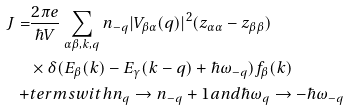<formula> <loc_0><loc_0><loc_500><loc_500>J = & \frac { 2 \pi e } { \hbar { V } } \sum _ { \alpha \beta , { k } , { q } } n _ { - { q } } | V _ { \beta \alpha } ( { q } ) | ^ { 2 } ( z _ { \alpha \alpha } - z _ { \beta \beta } ) \\ & \times \delta ( E _ { \beta } ( { k } ) - E _ { \gamma } ( { k } - { q } ) + \hbar { \omega } _ { - { q } } ) f _ { \beta } ( { k } ) \\ + & t e r m s w i t h n _ { q } \to n _ { - { q } } + 1 a n d \hbar { \omega } _ { q } \to - \hbar { \omega } _ { - { q } }</formula> 